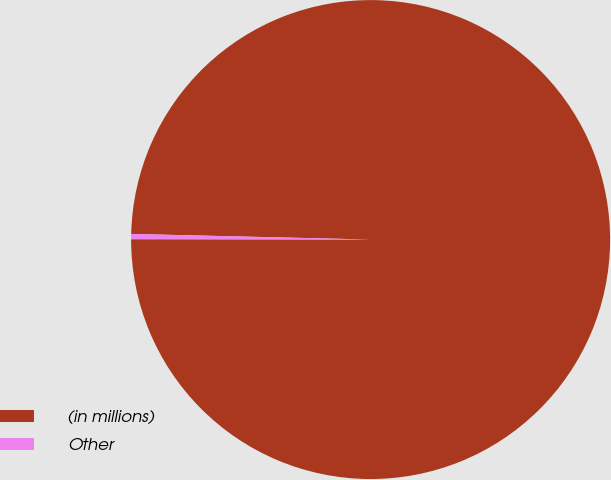<chart> <loc_0><loc_0><loc_500><loc_500><pie_chart><fcel>(in millions)<fcel>Other<nl><fcel>99.65%<fcel>0.35%<nl></chart> 